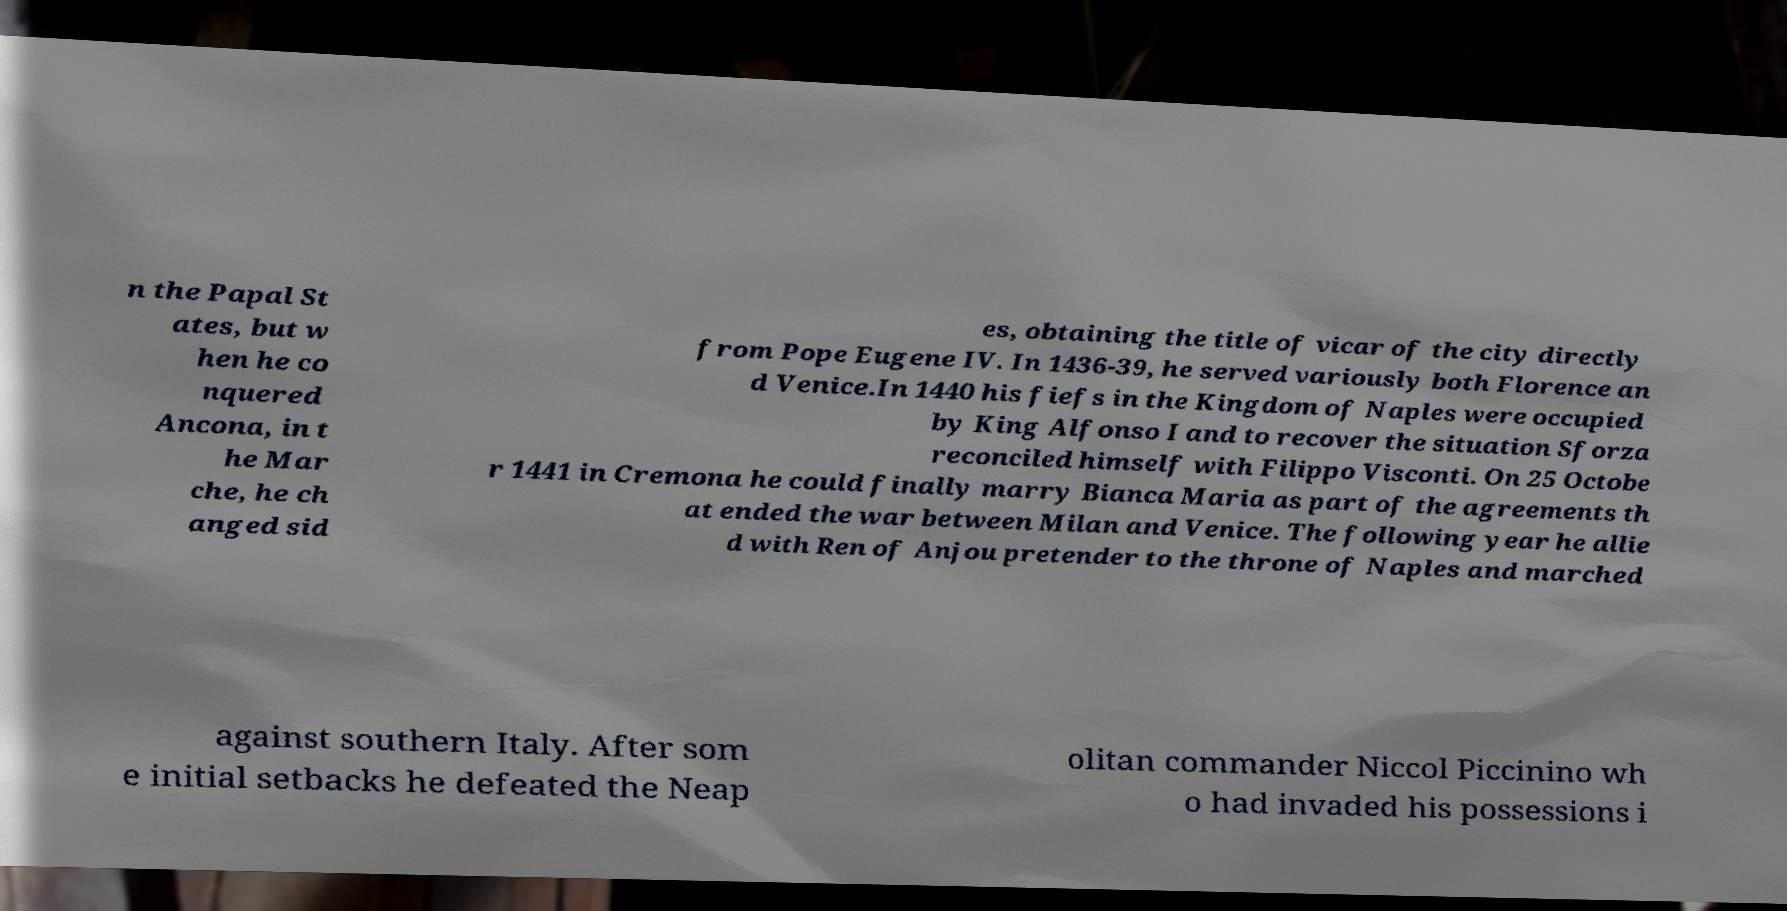Could you extract and type out the text from this image? n the Papal St ates, but w hen he co nquered Ancona, in t he Mar che, he ch anged sid es, obtaining the title of vicar of the city directly from Pope Eugene IV. In 1436-39, he served variously both Florence an d Venice.In 1440 his fiefs in the Kingdom of Naples were occupied by King Alfonso I and to recover the situation Sforza reconciled himself with Filippo Visconti. On 25 Octobe r 1441 in Cremona he could finally marry Bianca Maria as part of the agreements th at ended the war between Milan and Venice. The following year he allie d with Ren of Anjou pretender to the throne of Naples and marched against southern Italy. After som e initial setbacks he defeated the Neap olitan commander Niccol Piccinino wh o had invaded his possessions i 